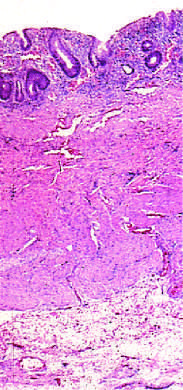does this section show that disease is limited to the mucosa?
Answer the question using a single word or phrase. No 